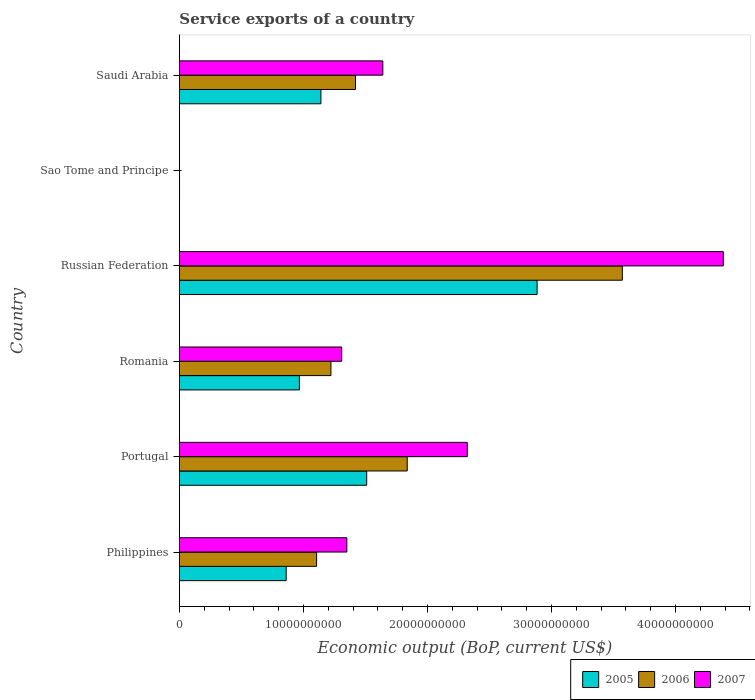How many different coloured bars are there?
Make the answer very short. 3. How many groups of bars are there?
Offer a terse response. 6. Are the number of bars on each tick of the Y-axis equal?
Provide a short and direct response. Yes. How many bars are there on the 1st tick from the top?
Keep it short and to the point. 3. How many bars are there on the 3rd tick from the bottom?
Offer a very short reply. 3. What is the service exports in 2006 in Philippines?
Your answer should be very brief. 1.11e+1. Across all countries, what is the maximum service exports in 2005?
Ensure brevity in your answer.  2.88e+1. Across all countries, what is the minimum service exports in 2007?
Offer a very short reply. 6.70e+06. In which country was the service exports in 2006 maximum?
Give a very brief answer. Russian Federation. In which country was the service exports in 2005 minimum?
Offer a terse response. Sao Tome and Principe. What is the total service exports in 2007 in the graph?
Offer a very short reply. 1.10e+11. What is the difference between the service exports in 2006 in Portugal and that in Sao Tome and Principe?
Ensure brevity in your answer.  1.84e+1. What is the difference between the service exports in 2006 in Saudi Arabia and the service exports in 2005 in Philippines?
Your answer should be very brief. 5.59e+09. What is the average service exports in 2005 per country?
Offer a terse response. 1.23e+1. What is the difference between the service exports in 2007 and service exports in 2006 in Philippines?
Your answer should be compact. 2.44e+09. What is the ratio of the service exports in 2007 in Russian Federation to that in Sao Tome and Principe?
Provide a short and direct response. 6546.11. Is the service exports in 2006 in Philippines less than that in Saudi Arabia?
Offer a terse response. Yes. Is the difference between the service exports in 2007 in Romania and Sao Tome and Principe greater than the difference between the service exports in 2006 in Romania and Sao Tome and Principe?
Provide a succinct answer. Yes. What is the difference between the highest and the second highest service exports in 2006?
Your answer should be very brief. 1.73e+1. What is the difference between the highest and the lowest service exports in 2006?
Ensure brevity in your answer.  3.57e+1. Is the sum of the service exports in 2006 in Romania and Saudi Arabia greater than the maximum service exports in 2007 across all countries?
Provide a succinct answer. No. What does the 3rd bar from the top in Saudi Arabia represents?
Make the answer very short. 2005. Is it the case that in every country, the sum of the service exports in 2007 and service exports in 2006 is greater than the service exports in 2005?
Your answer should be compact. Yes. What is the difference between two consecutive major ticks on the X-axis?
Offer a terse response. 1.00e+1. Does the graph contain any zero values?
Keep it short and to the point. No. How many legend labels are there?
Give a very brief answer. 3. How are the legend labels stacked?
Your answer should be very brief. Horizontal. What is the title of the graph?
Offer a very short reply. Service exports of a country. What is the label or title of the X-axis?
Your answer should be compact. Economic output (BoP, current US$). What is the Economic output (BoP, current US$) in 2005 in Philippines?
Offer a terse response. 8.61e+09. What is the Economic output (BoP, current US$) in 2006 in Philippines?
Ensure brevity in your answer.  1.11e+1. What is the Economic output (BoP, current US$) of 2007 in Philippines?
Make the answer very short. 1.35e+1. What is the Economic output (BoP, current US$) of 2005 in Portugal?
Keep it short and to the point. 1.51e+1. What is the Economic output (BoP, current US$) in 2006 in Portugal?
Give a very brief answer. 1.84e+1. What is the Economic output (BoP, current US$) of 2007 in Portugal?
Provide a succinct answer. 2.32e+1. What is the Economic output (BoP, current US$) of 2005 in Romania?
Offer a very short reply. 9.68e+09. What is the Economic output (BoP, current US$) of 2006 in Romania?
Give a very brief answer. 1.22e+1. What is the Economic output (BoP, current US$) in 2007 in Romania?
Your answer should be compact. 1.31e+1. What is the Economic output (BoP, current US$) of 2005 in Russian Federation?
Make the answer very short. 2.88e+1. What is the Economic output (BoP, current US$) of 2006 in Russian Federation?
Provide a short and direct response. 3.57e+1. What is the Economic output (BoP, current US$) in 2007 in Russian Federation?
Your answer should be compact. 4.39e+1. What is the Economic output (BoP, current US$) in 2005 in Sao Tome and Principe?
Your answer should be compact. 9.15e+06. What is the Economic output (BoP, current US$) of 2006 in Sao Tome and Principe?
Offer a terse response. 8.40e+06. What is the Economic output (BoP, current US$) of 2007 in Sao Tome and Principe?
Your answer should be very brief. 6.70e+06. What is the Economic output (BoP, current US$) of 2005 in Saudi Arabia?
Give a very brief answer. 1.14e+1. What is the Economic output (BoP, current US$) of 2006 in Saudi Arabia?
Give a very brief answer. 1.42e+1. What is the Economic output (BoP, current US$) in 2007 in Saudi Arabia?
Give a very brief answer. 1.64e+1. Across all countries, what is the maximum Economic output (BoP, current US$) in 2005?
Your answer should be very brief. 2.88e+1. Across all countries, what is the maximum Economic output (BoP, current US$) in 2006?
Provide a succinct answer. 3.57e+1. Across all countries, what is the maximum Economic output (BoP, current US$) in 2007?
Ensure brevity in your answer.  4.39e+1. Across all countries, what is the minimum Economic output (BoP, current US$) in 2005?
Offer a very short reply. 9.15e+06. Across all countries, what is the minimum Economic output (BoP, current US$) of 2006?
Your answer should be compact. 8.40e+06. Across all countries, what is the minimum Economic output (BoP, current US$) of 2007?
Keep it short and to the point. 6.70e+06. What is the total Economic output (BoP, current US$) of 2005 in the graph?
Offer a terse response. 7.37e+1. What is the total Economic output (BoP, current US$) of 2006 in the graph?
Ensure brevity in your answer.  9.16e+1. What is the total Economic output (BoP, current US$) in 2007 in the graph?
Make the answer very short. 1.10e+11. What is the difference between the Economic output (BoP, current US$) of 2005 in Philippines and that in Portugal?
Offer a terse response. -6.49e+09. What is the difference between the Economic output (BoP, current US$) in 2006 in Philippines and that in Portugal?
Provide a short and direct response. -7.31e+09. What is the difference between the Economic output (BoP, current US$) of 2007 in Philippines and that in Portugal?
Make the answer very short. -9.71e+09. What is the difference between the Economic output (BoP, current US$) in 2005 in Philippines and that in Romania?
Provide a succinct answer. -1.06e+09. What is the difference between the Economic output (BoP, current US$) in 2006 in Philippines and that in Romania?
Offer a very short reply. -1.15e+09. What is the difference between the Economic output (BoP, current US$) in 2007 in Philippines and that in Romania?
Your answer should be very brief. 4.12e+08. What is the difference between the Economic output (BoP, current US$) in 2005 in Philippines and that in Russian Federation?
Your answer should be compact. -2.02e+1. What is the difference between the Economic output (BoP, current US$) in 2006 in Philippines and that in Russian Federation?
Your response must be concise. -2.47e+1. What is the difference between the Economic output (BoP, current US$) of 2007 in Philippines and that in Russian Federation?
Make the answer very short. -3.04e+1. What is the difference between the Economic output (BoP, current US$) of 2005 in Philippines and that in Sao Tome and Principe?
Provide a succinct answer. 8.60e+09. What is the difference between the Economic output (BoP, current US$) of 2006 in Philippines and that in Sao Tome and Principe?
Give a very brief answer. 1.11e+1. What is the difference between the Economic output (BoP, current US$) of 2007 in Philippines and that in Sao Tome and Principe?
Provide a short and direct response. 1.35e+1. What is the difference between the Economic output (BoP, current US$) of 2005 in Philippines and that in Saudi Arabia?
Offer a very short reply. -2.80e+09. What is the difference between the Economic output (BoP, current US$) of 2006 in Philippines and that in Saudi Arabia?
Ensure brevity in your answer.  -3.14e+09. What is the difference between the Economic output (BoP, current US$) of 2007 in Philippines and that in Saudi Arabia?
Offer a very short reply. -2.90e+09. What is the difference between the Economic output (BoP, current US$) of 2005 in Portugal and that in Romania?
Offer a terse response. 5.43e+09. What is the difference between the Economic output (BoP, current US$) in 2006 in Portugal and that in Romania?
Provide a short and direct response. 6.15e+09. What is the difference between the Economic output (BoP, current US$) of 2007 in Portugal and that in Romania?
Your response must be concise. 1.01e+1. What is the difference between the Economic output (BoP, current US$) in 2005 in Portugal and that in Russian Federation?
Provide a short and direct response. -1.37e+1. What is the difference between the Economic output (BoP, current US$) in 2006 in Portugal and that in Russian Federation?
Make the answer very short. -1.73e+1. What is the difference between the Economic output (BoP, current US$) of 2007 in Portugal and that in Russian Federation?
Your response must be concise. -2.06e+1. What is the difference between the Economic output (BoP, current US$) of 2005 in Portugal and that in Sao Tome and Principe?
Your response must be concise. 1.51e+1. What is the difference between the Economic output (BoP, current US$) in 2006 in Portugal and that in Sao Tome and Principe?
Offer a very short reply. 1.84e+1. What is the difference between the Economic output (BoP, current US$) in 2007 in Portugal and that in Sao Tome and Principe?
Provide a succinct answer. 2.32e+1. What is the difference between the Economic output (BoP, current US$) of 2005 in Portugal and that in Saudi Arabia?
Offer a terse response. 3.69e+09. What is the difference between the Economic output (BoP, current US$) of 2006 in Portugal and that in Saudi Arabia?
Your response must be concise. 4.17e+09. What is the difference between the Economic output (BoP, current US$) of 2007 in Portugal and that in Saudi Arabia?
Your answer should be compact. 6.81e+09. What is the difference between the Economic output (BoP, current US$) in 2005 in Romania and that in Russian Federation?
Make the answer very short. -1.92e+1. What is the difference between the Economic output (BoP, current US$) in 2006 in Romania and that in Russian Federation?
Your answer should be very brief. -2.35e+1. What is the difference between the Economic output (BoP, current US$) of 2007 in Romania and that in Russian Federation?
Make the answer very short. -3.08e+1. What is the difference between the Economic output (BoP, current US$) in 2005 in Romania and that in Sao Tome and Principe?
Offer a very short reply. 9.67e+09. What is the difference between the Economic output (BoP, current US$) of 2006 in Romania and that in Sao Tome and Principe?
Your response must be concise. 1.22e+1. What is the difference between the Economic output (BoP, current US$) of 2007 in Romania and that in Sao Tome and Principe?
Your response must be concise. 1.31e+1. What is the difference between the Economic output (BoP, current US$) in 2005 in Romania and that in Saudi Arabia?
Your response must be concise. -1.73e+09. What is the difference between the Economic output (BoP, current US$) of 2006 in Romania and that in Saudi Arabia?
Give a very brief answer. -1.98e+09. What is the difference between the Economic output (BoP, current US$) in 2007 in Romania and that in Saudi Arabia?
Ensure brevity in your answer.  -3.31e+09. What is the difference between the Economic output (BoP, current US$) of 2005 in Russian Federation and that in Sao Tome and Principe?
Keep it short and to the point. 2.88e+1. What is the difference between the Economic output (BoP, current US$) of 2006 in Russian Federation and that in Sao Tome and Principe?
Your answer should be very brief. 3.57e+1. What is the difference between the Economic output (BoP, current US$) in 2007 in Russian Federation and that in Sao Tome and Principe?
Keep it short and to the point. 4.39e+1. What is the difference between the Economic output (BoP, current US$) of 2005 in Russian Federation and that in Saudi Arabia?
Ensure brevity in your answer.  1.74e+1. What is the difference between the Economic output (BoP, current US$) in 2006 in Russian Federation and that in Saudi Arabia?
Provide a succinct answer. 2.15e+1. What is the difference between the Economic output (BoP, current US$) of 2007 in Russian Federation and that in Saudi Arabia?
Your answer should be compact. 2.75e+1. What is the difference between the Economic output (BoP, current US$) of 2005 in Sao Tome and Principe and that in Saudi Arabia?
Your answer should be compact. -1.14e+1. What is the difference between the Economic output (BoP, current US$) of 2006 in Sao Tome and Principe and that in Saudi Arabia?
Your answer should be compact. -1.42e+1. What is the difference between the Economic output (BoP, current US$) of 2007 in Sao Tome and Principe and that in Saudi Arabia?
Offer a terse response. -1.64e+1. What is the difference between the Economic output (BoP, current US$) in 2005 in Philippines and the Economic output (BoP, current US$) in 2006 in Portugal?
Your response must be concise. -9.76e+09. What is the difference between the Economic output (BoP, current US$) in 2005 in Philippines and the Economic output (BoP, current US$) in 2007 in Portugal?
Make the answer very short. -1.46e+1. What is the difference between the Economic output (BoP, current US$) in 2006 in Philippines and the Economic output (BoP, current US$) in 2007 in Portugal?
Keep it short and to the point. -1.22e+1. What is the difference between the Economic output (BoP, current US$) of 2005 in Philippines and the Economic output (BoP, current US$) of 2006 in Romania?
Provide a succinct answer. -3.61e+09. What is the difference between the Economic output (BoP, current US$) of 2005 in Philippines and the Economic output (BoP, current US$) of 2007 in Romania?
Ensure brevity in your answer.  -4.48e+09. What is the difference between the Economic output (BoP, current US$) in 2006 in Philippines and the Economic output (BoP, current US$) in 2007 in Romania?
Provide a succinct answer. -2.03e+09. What is the difference between the Economic output (BoP, current US$) in 2005 in Philippines and the Economic output (BoP, current US$) in 2006 in Russian Federation?
Give a very brief answer. -2.71e+1. What is the difference between the Economic output (BoP, current US$) in 2005 in Philippines and the Economic output (BoP, current US$) in 2007 in Russian Federation?
Offer a terse response. -3.52e+1. What is the difference between the Economic output (BoP, current US$) of 2006 in Philippines and the Economic output (BoP, current US$) of 2007 in Russian Federation?
Keep it short and to the point. -3.28e+1. What is the difference between the Economic output (BoP, current US$) in 2005 in Philippines and the Economic output (BoP, current US$) in 2006 in Sao Tome and Principe?
Offer a terse response. 8.60e+09. What is the difference between the Economic output (BoP, current US$) of 2005 in Philippines and the Economic output (BoP, current US$) of 2007 in Sao Tome and Principe?
Make the answer very short. 8.60e+09. What is the difference between the Economic output (BoP, current US$) of 2006 in Philippines and the Economic output (BoP, current US$) of 2007 in Sao Tome and Principe?
Give a very brief answer. 1.11e+1. What is the difference between the Economic output (BoP, current US$) in 2005 in Philippines and the Economic output (BoP, current US$) in 2006 in Saudi Arabia?
Offer a very short reply. -5.59e+09. What is the difference between the Economic output (BoP, current US$) in 2005 in Philippines and the Economic output (BoP, current US$) in 2007 in Saudi Arabia?
Your answer should be compact. -7.79e+09. What is the difference between the Economic output (BoP, current US$) in 2006 in Philippines and the Economic output (BoP, current US$) in 2007 in Saudi Arabia?
Your answer should be very brief. -5.34e+09. What is the difference between the Economic output (BoP, current US$) of 2005 in Portugal and the Economic output (BoP, current US$) of 2006 in Romania?
Your answer should be very brief. 2.88e+09. What is the difference between the Economic output (BoP, current US$) of 2005 in Portugal and the Economic output (BoP, current US$) of 2007 in Romania?
Your response must be concise. 2.01e+09. What is the difference between the Economic output (BoP, current US$) in 2006 in Portugal and the Economic output (BoP, current US$) in 2007 in Romania?
Your answer should be very brief. 5.28e+09. What is the difference between the Economic output (BoP, current US$) in 2005 in Portugal and the Economic output (BoP, current US$) in 2006 in Russian Federation?
Your answer should be compact. -2.06e+1. What is the difference between the Economic output (BoP, current US$) of 2005 in Portugal and the Economic output (BoP, current US$) of 2007 in Russian Federation?
Give a very brief answer. -2.88e+1. What is the difference between the Economic output (BoP, current US$) of 2006 in Portugal and the Economic output (BoP, current US$) of 2007 in Russian Federation?
Offer a very short reply. -2.55e+1. What is the difference between the Economic output (BoP, current US$) in 2005 in Portugal and the Economic output (BoP, current US$) in 2006 in Sao Tome and Principe?
Ensure brevity in your answer.  1.51e+1. What is the difference between the Economic output (BoP, current US$) in 2005 in Portugal and the Economic output (BoP, current US$) in 2007 in Sao Tome and Principe?
Give a very brief answer. 1.51e+1. What is the difference between the Economic output (BoP, current US$) in 2006 in Portugal and the Economic output (BoP, current US$) in 2007 in Sao Tome and Principe?
Give a very brief answer. 1.84e+1. What is the difference between the Economic output (BoP, current US$) in 2005 in Portugal and the Economic output (BoP, current US$) in 2006 in Saudi Arabia?
Give a very brief answer. 9.00e+08. What is the difference between the Economic output (BoP, current US$) in 2005 in Portugal and the Economic output (BoP, current US$) in 2007 in Saudi Arabia?
Your answer should be very brief. -1.30e+09. What is the difference between the Economic output (BoP, current US$) in 2006 in Portugal and the Economic output (BoP, current US$) in 2007 in Saudi Arabia?
Make the answer very short. 1.97e+09. What is the difference between the Economic output (BoP, current US$) in 2005 in Romania and the Economic output (BoP, current US$) in 2006 in Russian Federation?
Ensure brevity in your answer.  -2.60e+1. What is the difference between the Economic output (BoP, current US$) of 2005 in Romania and the Economic output (BoP, current US$) of 2007 in Russian Federation?
Give a very brief answer. -3.42e+1. What is the difference between the Economic output (BoP, current US$) of 2006 in Romania and the Economic output (BoP, current US$) of 2007 in Russian Federation?
Offer a terse response. -3.16e+1. What is the difference between the Economic output (BoP, current US$) of 2005 in Romania and the Economic output (BoP, current US$) of 2006 in Sao Tome and Principe?
Ensure brevity in your answer.  9.67e+09. What is the difference between the Economic output (BoP, current US$) of 2005 in Romania and the Economic output (BoP, current US$) of 2007 in Sao Tome and Principe?
Offer a terse response. 9.67e+09. What is the difference between the Economic output (BoP, current US$) of 2006 in Romania and the Economic output (BoP, current US$) of 2007 in Sao Tome and Principe?
Provide a succinct answer. 1.22e+1. What is the difference between the Economic output (BoP, current US$) of 2005 in Romania and the Economic output (BoP, current US$) of 2006 in Saudi Arabia?
Your answer should be very brief. -4.53e+09. What is the difference between the Economic output (BoP, current US$) of 2005 in Romania and the Economic output (BoP, current US$) of 2007 in Saudi Arabia?
Provide a succinct answer. -6.73e+09. What is the difference between the Economic output (BoP, current US$) of 2006 in Romania and the Economic output (BoP, current US$) of 2007 in Saudi Arabia?
Your response must be concise. -4.19e+09. What is the difference between the Economic output (BoP, current US$) in 2005 in Russian Federation and the Economic output (BoP, current US$) in 2006 in Sao Tome and Principe?
Your response must be concise. 2.88e+1. What is the difference between the Economic output (BoP, current US$) in 2005 in Russian Federation and the Economic output (BoP, current US$) in 2007 in Sao Tome and Principe?
Make the answer very short. 2.88e+1. What is the difference between the Economic output (BoP, current US$) of 2006 in Russian Federation and the Economic output (BoP, current US$) of 2007 in Sao Tome and Principe?
Make the answer very short. 3.57e+1. What is the difference between the Economic output (BoP, current US$) in 2005 in Russian Federation and the Economic output (BoP, current US$) in 2006 in Saudi Arabia?
Give a very brief answer. 1.46e+1. What is the difference between the Economic output (BoP, current US$) in 2005 in Russian Federation and the Economic output (BoP, current US$) in 2007 in Saudi Arabia?
Offer a terse response. 1.24e+1. What is the difference between the Economic output (BoP, current US$) of 2006 in Russian Federation and the Economic output (BoP, current US$) of 2007 in Saudi Arabia?
Your answer should be compact. 1.93e+1. What is the difference between the Economic output (BoP, current US$) of 2005 in Sao Tome and Principe and the Economic output (BoP, current US$) of 2006 in Saudi Arabia?
Offer a very short reply. -1.42e+1. What is the difference between the Economic output (BoP, current US$) of 2005 in Sao Tome and Principe and the Economic output (BoP, current US$) of 2007 in Saudi Arabia?
Offer a very short reply. -1.64e+1. What is the difference between the Economic output (BoP, current US$) of 2006 in Sao Tome and Principe and the Economic output (BoP, current US$) of 2007 in Saudi Arabia?
Provide a short and direct response. -1.64e+1. What is the average Economic output (BoP, current US$) of 2005 per country?
Give a very brief answer. 1.23e+1. What is the average Economic output (BoP, current US$) in 2006 per country?
Ensure brevity in your answer.  1.53e+1. What is the average Economic output (BoP, current US$) of 2007 per country?
Provide a succinct answer. 1.83e+1. What is the difference between the Economic output (BoP, current US$) in 2005 and Economic output (BoP, current US$) in 2006 in Philippines?
Provide a short and direct response. -2.45e+09. What is the difference between the Economic output (BoP, current US$) of 2005 and Economic output (BoP, current US$) of 2007 in Philippines?
Provide a succinct answer. -4.89e+09. What is the difference between the Economic output (BoP, current US$) of 2006 and Economic output (BoP, current US$) of 2007 in Philippines?
Offer a very short reply. -2.44e+09. What is the difference between the Economic output (BoP, current US$) in 2005 and Economic output (BoP, current US$) in 2006 in Portugal?
Your response must be concise. -3.27e+09. What is the difference between the Economic output (BoP, current US$) in 2005 and Economic output (BoP, current US$) in 2007 in Portugal?
Make the answer very short. -8.11e+09. What is the difference between the Economic output (BoP, current US$) of 2006 and Economic output (BoP, current US$) of 2007 in Portugal?
Ensure brevity in your answer.  -4.84e+09. What is the difference between the Economic output (BoP, current US$) of 2005 and Economic output (BoP, current US$) of 2006 in Romania?
Your response must be concise. -2.54e+09. What is the difference between the Economic output (BoP, current US$) of 2005 and Economic output (BoP, current US$) of 2007 in Romania?
Make the answer very short. -3.41e+09. What is the difference between the Economic output (BoP, current US$) of 2006 and Economic output (BoP, current US$) of 2007 in Romania?
Make the answer very short. -8.71e+08. What is the difference between the Economic output (BoP, current US$) of 2005 and Economic output (BoP, current US$) of 2006 in Russian Federation?
Your response must be concise. -6.87e+09. What is the difference between the Economic output (BoP, current US$) of 2005 and Economic output (BoP, current US$) of 2007 in Russian Federation?
Your answer should be compact. -1.50e+1. What is the difference between the Economic output (BoP, current US$) in 2006 and Economic output (BoP, current US$) in 2007 in Russian Federation?
Provide a short and direct response. -8.14e+09. What is the difference between the Economic output (BoP, current US$) of 2005 and Economic output (BoP, current US$) of 2006 in Sao Tome and Principe?
Your answer should be very brief. 7.49e+05. What is the difference between the Economic output (BoP, current US$) of 2005 and Economic output (BoP, current US$) of 2007 in Sao Tome and Principe?
Ensure brevity in your answer.  2.45e+06. What is the difference between the Economic output (BoP, current US$) in 2006 and Economic output (BoP, current US$) in 2007 in Sao Tome and Principe?
Keep it short and to the point. 1.70e+06. What is the difference between the Economic output (BoP, current US$) in 2005 and Economic output (BoP, current US$) in 2006 in Saudi Arabia?
Provide a succinct answer. -2.79e+09. What is the difference between the Economic output (BoP, current US$) in 2005 and Economic output (BoP, current US$) in 2007 in Saudi Arabia?
Your answer should be very brief. -4.99e+09. What is the difference between the Economic output (BoP, current US$) in 2006 and Economic output (BoP, current US$) in 2007 in Saudi Arabia?
Give a very brief answer. -2.20e+09. What is the ratio of the Economic output (BoP, current US$) of 2005 in Philippines to that in Portugal?
Your answer should be very brief. 0.57. What is the ratio of the Economic output (BoP, current US$) of 2006 in Philippines to that in Portugal?
Make the answer very short. 0.6. What is the ratio of the Economic output (BoP, current US$) in 2007 in Philippines to that in Portugal?
Offer a terse response. 0.58. What is the ratio of the Economic output (BoP, current US$) of 2005 in Philippines to that in Romania?
Offer a terse response. 0.89. What is the ratio of the Economic output (BoP, current US$) in 2006 in Philippines to that in Romania?
Provide a short and direct response. 0.91. What is the ratio of the Economic output (BoP, current US$) in 2007 in Philippines to that in Romania?
Your answer should be very brief. 1.03. What is the ratio of the Economic output (BoP, current US$) of 2005 in Philippines to that in Russian Federation?
Offer a very short reply. 0.3. What is the ratio of the Economic output (BoP, current US$) of 2006 in Philippines to that in Russian Federation?
Make the answer very short. 0.31. What is the ratio of the Economic output (BoP, current US$) in 2007 in Philippines to that in Russian Federation?
Ensure brevity in your answer.  0.31. What is the ratio of the Economic output (BoP, current US$) in 2005 in Philippines to that in Sao Tome and Principe?
Your answer should be very brief. 940.73. What is the ratio of the Economic output (BoP, current US$) of 2006 in Philippines to that in Sao Tome and Principe?
Keep it short and to the point. 1316.55. What is the ratio of the Economic output (BoP, current US$) in 2007 in Philippines to that in Sao Tome and Principe?
Your answer should be very brief. 2015.13. What is the ratio of the Economic output (BoP, current US$) of 2005 in Philippines to that in Saudi Arabia?
Keep it short and to the point. 0.75. What is the ratio of the Economic output (BoP, current US$) of 2006 in Philippines to that in Saudi Arabia?
Make the answer very short. 0.78. What is the ratio of the Economic output (BoP, current US$) in 2007 in Philippines to that in Saudi Arabia?
Your answer should be very brief. 0.82. What is the ratio of the Economic output (BoP, current US$) in 2005 in Portugal to that in Romania?
Provide a short and direct response. 1.56. What is the ratio of the Economic output (BoP, current US$) in 2006 in Portugal to that in Romania?
Provide a succinct answer. 1.5. What is the ratio of the Economic output (BoP, current US$) in 2007 in Portugal to that in Romania?
Your response must be concise. 1.77. What is the ratio of the Economic output (BoP, current US$) in 2005 in Portugal to that in Russian Federation?
Provide a short and direct response. 0.52. What is the ratio of the Economic output (BoP, current US$) in 2006 in Portugal to that in Russian Federation?
Your response must be concise. 0.51. What is the ratio of the Economic output (BoP, current US$) in 2007 in Portugal to that in Russian Federation?
Keep it short and to the point. 0.53. What is the ratio of the Economic output (BoP, current US$) in 2005 in Portugal to that in Sao Tome and Principe?
Offer a very short reply. 1649.84. What is the ratio of the Economic output (BoP, current US$) in 2006 in Portugal to that in Sao Tome and Principe?
Your answer should be very brief. 2186.12. What is the ratio of the Economic output (BoP, current US$) in 2007 in Portugal to that in Sao Tome and Principe?
Offer a very short reply. 3464.91. What is the ratio of the Economic output (BoP, current US$) of 2005 in Portugal to that in Saudi Arabia?
Offer a terse response. 1.32. What is the ratio of the Economic output (BoP, current US$) of 2006 in Portugal to that in Saudi Arabia?
Keep it short and to the point. 1.29. What is the ratio of the Economic output (BoP, current US$) of 2007 in Portugal to that in Saudi Arabia?
Your response must be concise. 1.42. What is the ratio of the Economic output (BoP, current US$) in 2005 in Romania to that in Russian Federation?
Ensure brevity in your answer.  0.34. What is the ratio of the Economic output (BoP, current US$) in 2006 in Romania to that in Russian Federation?
Offer a terse response. 0.34. What is the ratio of the Economic output (BoP, current US$) of 2007 in Romania to that in Russian Federation?
Your answer should be compact. 0.3. What is the ratio of the Economic output (BoP, current US$) in 2005 in Romania to that in Sao Tome and Principe?
Provide a succinct answer. 1057.08. What is the ratio of the Economic output (BoP, current US$) of 2006 in Romania to that in Sao Tome and Principe?
Ensure brevity in your answer.  1453.91. What is the ratio of the Economic output (BoP, current US$) of 2007 in Romania to that in Sao Tome and Principe?
Provide a short and direct response. 1953.68. What is the ratio of the Economic output (BoP, current US$) in 2005 in Romania to that in Saudi Arabia?
Your answer should be very brief. 0.85. What is the ratio of the Economic output (BoP, current US$) in 2006 in Romania to that in Saudi Arabia?
Make the answer very short. 0.86. What is the ratio of the Economic output (BoP, current US$) of 2007 in Romania to that in Saudi Arabia?
Offer a terse response. 0.8. What is the ratio of the Economic output (BoP, current US$) in 2005 in Russian Federation to that in Sao Tome and Principe?
Provide a succinct answer. 3151.33. What is the ratio of the Economic output (BoP, current US$) of 2006 in Russian Federation to that in Sao Tome and Principe?
Make the answer very short. 4250.2. What is the ratio of the Economic output (BoP, current US$) of 2007 in Russian Federation to that in Sao Tome and Principe?
Offer a very short reply. 6546.11. What is the ratio of the Economic output (BoP, current US$) of 2005 in Russian Federation to that in Saudi Arabia?
Your answer should be compact. 2.53. What is the ratio of the Economic output (BoP, current US$) in 2006 in Russian Federation to that in Saudi Arabia?
Make the answer very short. 2.52. What is the ratio of the Economic output (BoP, current US$) in 2007 in Russian Federation to that in Saudi Arabia?
Provide a short and direct response. 2.67. What is the ratio of the Economic output (BoP, current US$) in 2005 in Sao Tome and Principe to that in Saudi Arabia?
Your response must be concise. 0. What is the ratio of the Economic output (BoP, current US$) in 2006 in Sao Tome and Principe to that in Saudi Arabia?
Your answer should be very brief. 0. What is the ratio of the Economic output (BoP, current US$) in 2007 in Sao Tome and Principe to that in Saudi Arabia?
Keep it short and to the point. 0. What is the difference between the highest and the second highest Economic output (BoP, current US$) in 2005?
Your answer should be compact. 1.37e+1. What is the difference between the highest and the second highest Economic output (BoP, current US$) of 2006?
Your answer should be very brief. 1.73e+1. What is the difference between the highest and the second highest Economic output (BoP, current US$) of 2007?
Offer a terse response. 2.06e+1. What is the difference between the highest and the lowest Economic output (BoP, current US$) of 2005?
Keep it short and to the point. 2.88e+1. What is the difference between the highest and the lowest Economic output (BoP, current US$) in 2006?
Offer a very short reply. 3.57e+1. What is the difference between the highest and the lowest Economic output (BoP, current US$) of 2007?
Your response must be concise. 4.39e+1. 